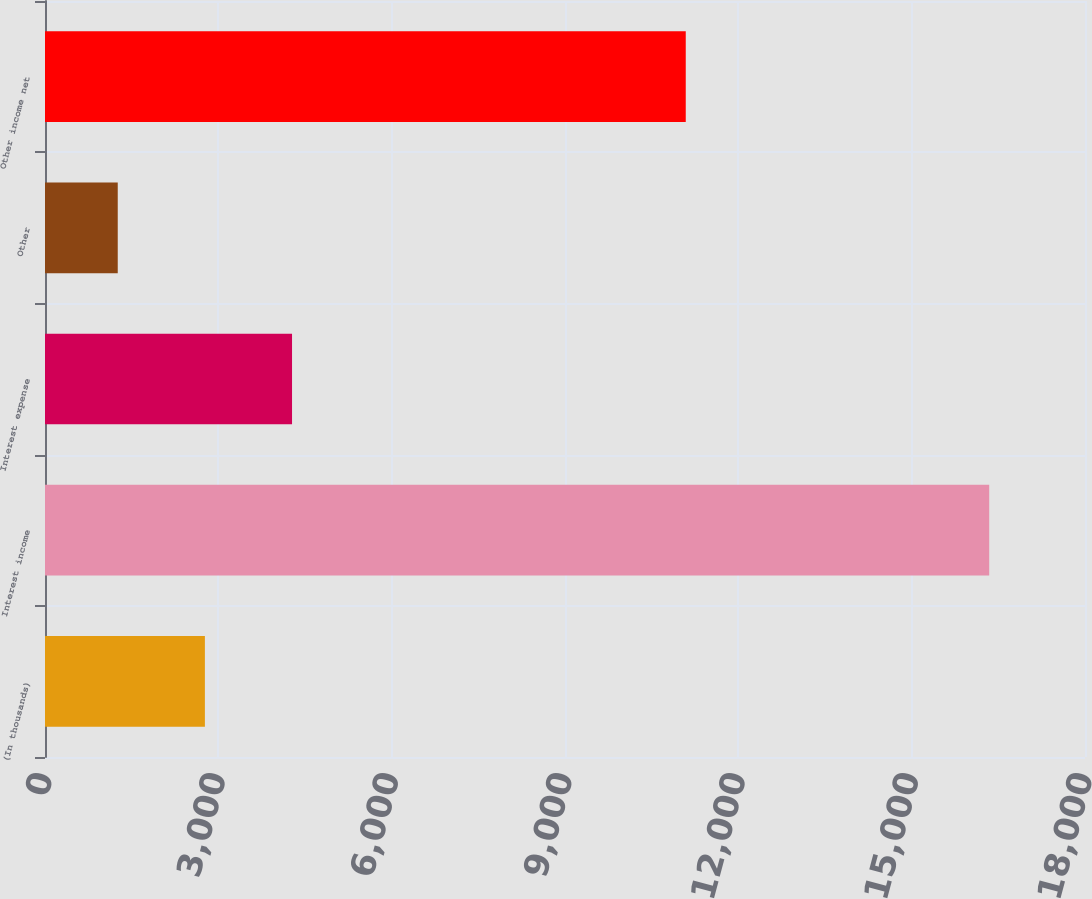Convert chart. <chart><loc_0><loc_0><loc_500><loc_500><bar_chart><fcel>(In thousands)<fcel>Interest income<fcel>Interest expense<fcel>Other<fcel>Other income net<nl><fcel>2767.3<fcel>16342<fcel>4275.6<fcel>1259<fcel>11090<nl></chart> 